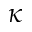<formula> <loc_0><loc_0><loc_500><loc_500>\kappa</formula> 